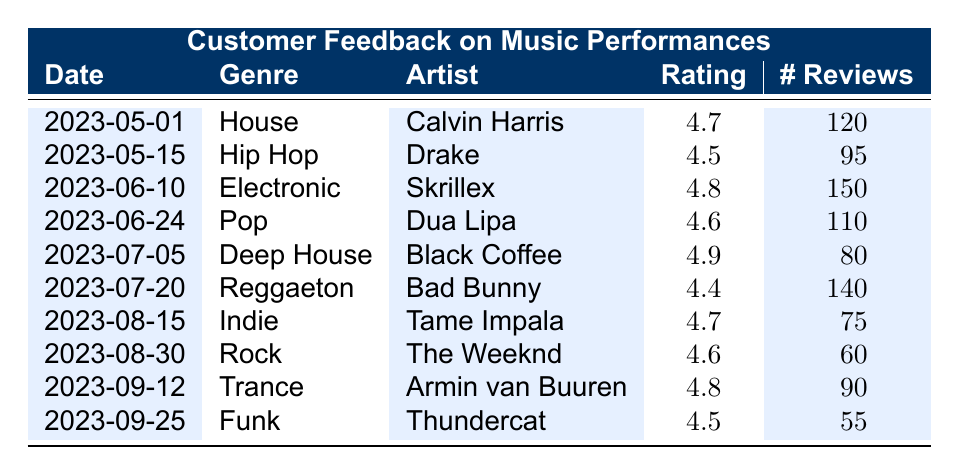What is the feedback rating for the Deep House music genre? The feedback rating for the Deep House music genre, performed by Black Coffee on July 5, 2023, is listed as 4.9 in the table.
Answer: 4.9 Which artist had the most reviews, and how many were there? By comparing the "number of reviews" column, Skrillex, who performed on June 10, 2023, had the most reviews with a total of 150 reviews.
Answer: Skrillex, 150 What is the average feedback rating across all genres performed in the club? To find the average, we sum up all the feedback ratings: (4.7 + 4.5 + 4.8 + 4.6 + 4.9 + 4.4 + 4.7 + 4.6 + 4.8 + 4.5) = 46.5. Then, we divide by the number of genres (10) to calculate the average: 46.5 / 10 = 4.65.
Answer: 4.65 Is there a feedback rating of 5.0 or higher in the table? No, after reviewing all the feedback ratings in the table, none of them reach or exceed a value of 5.0. The highest rating is 4.9.
Answer: No How many reviews did the Indie music genre receive compared to the Funk genre? For the Indie genre, there were 75 reviews, while the Funk genre had 55 reviews. Since 75 is greater than 55, we conclude that the Indie genre received more reviews.
Answer: Indie, 75; Funk, 55 What is the difference in feedback ratings between the highest-rated artist and the lowest-rated artist? The highest rating is 4.9 (Black Coffee) and the lowest rating is 4.4 (Bad Bunny). Calculating the difference: 4.9 - 4.4 = 0.5. Hence, the difference in feedback ratings is 0.5.
Answer: 0.5 Which genres received feedback ratings above 4.6? Looking at the feedback ratings, the genres that received ratings above 4.6 are House (4.7), Electronic (4.8), Deep House (4.9), Indie (4.7), and Trance (4.8).
Answer: House, Electronic, Deep House, Indie, Trance Did any artist perform more than once in the data provided? No, a review of the table shows that each artist is listed only once, indicating that none of them performed more than once in the given period.
Answer: No 